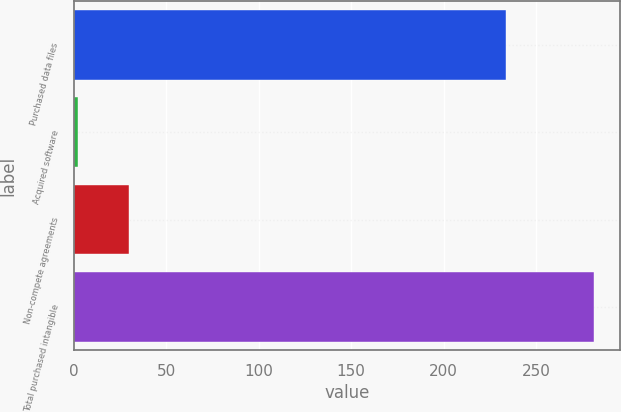Convert chart. <chart><loc_0><loc_0><loc_500><loc_500><bar_chart><fcel>Purchased data files<fcel>Acquired software<fcel>Non-compete agreements<fcel>Total purchased intangible<nl><fcel>233.7<fcel>2.2<fcel>30.11<fcel>281.3<nl></chart> 